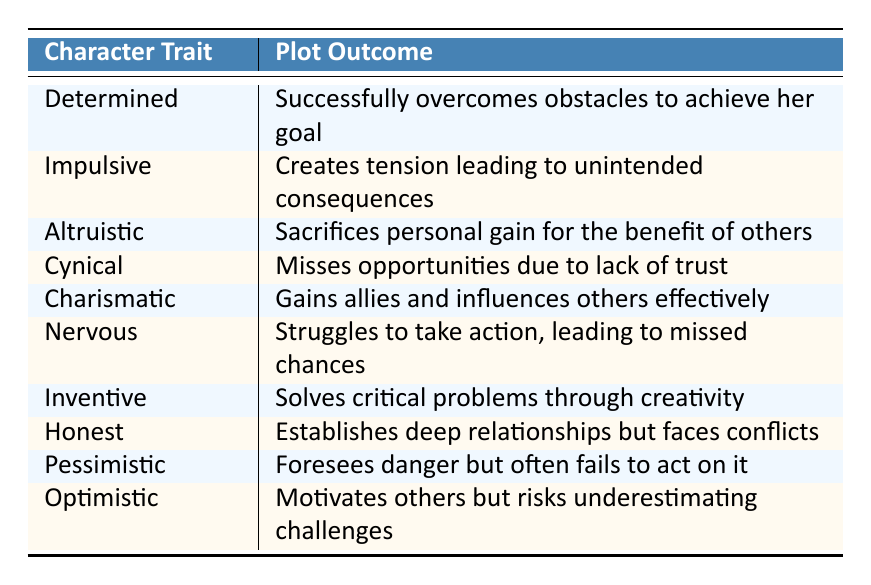What is the plot outcome for the character trait "Charismatic"? The table shows that the character trait "Charismatic" is linked to the plot outcome "Gains allies and influences others effectively."
Answer: Gains allies and influences others effectively Who is characterized as "Nervous"? According to the table, the character identified as "Nervous" is named "Nina."
Answer: Nina Is "Altruistic" associated with a positive plot outcome? Yes, the table indicates that the character trait "Altruistic" leads to the plot outcome where the character "Sacrifices personal gain for the benefit of others," which is typically considered positive.
Answer: Yes Which character traits result in missed opportunities? "Cynical" (Sofia) and "Nervous" (Nina) are the traits associated with missed opportunities according to their plot outcomes.
Answer: Cynical, Nervous What is the average number of plot outcomes mentioning action? The action-oriented outcomes are "Successfully overcomes obstacles to achieve her goal," "Struggles to take action, leading to missed chances," and "Solves critical problems through creativity," amounting to 3 action outcomes in total among 10 entries, leading to an average of 3/10.
Answer: 0.3 How many characters are characterized as having a trait that creates tension? The table shows that "Jordan" with the trait "Impulsive" creates tension leading to unintended consequences, hence there is 1 character with that feature.
Answer: 1 What is the relationship between being "Pessimistic" and plot outcomes? The character "Theo" is noted for being "Pessimistic" and tends to foresee danger but often fails to act on it, indicating a negative relationship in outcomes.
Answer: Negative relationship Which character shows the ability to solve problems creatively? The character "Owen" is identified with the trait "Inventive," which is linked to the plot outcome of solving critical problems through creativity.
Answer: Owen Do any characters have traits that lead to creating deep relationships? Yes, "Clara" is characterized as "Honest," which establishes deep relationships but faces conflicts, indicating that her trait does lead to such connections.
Answer: Yes 